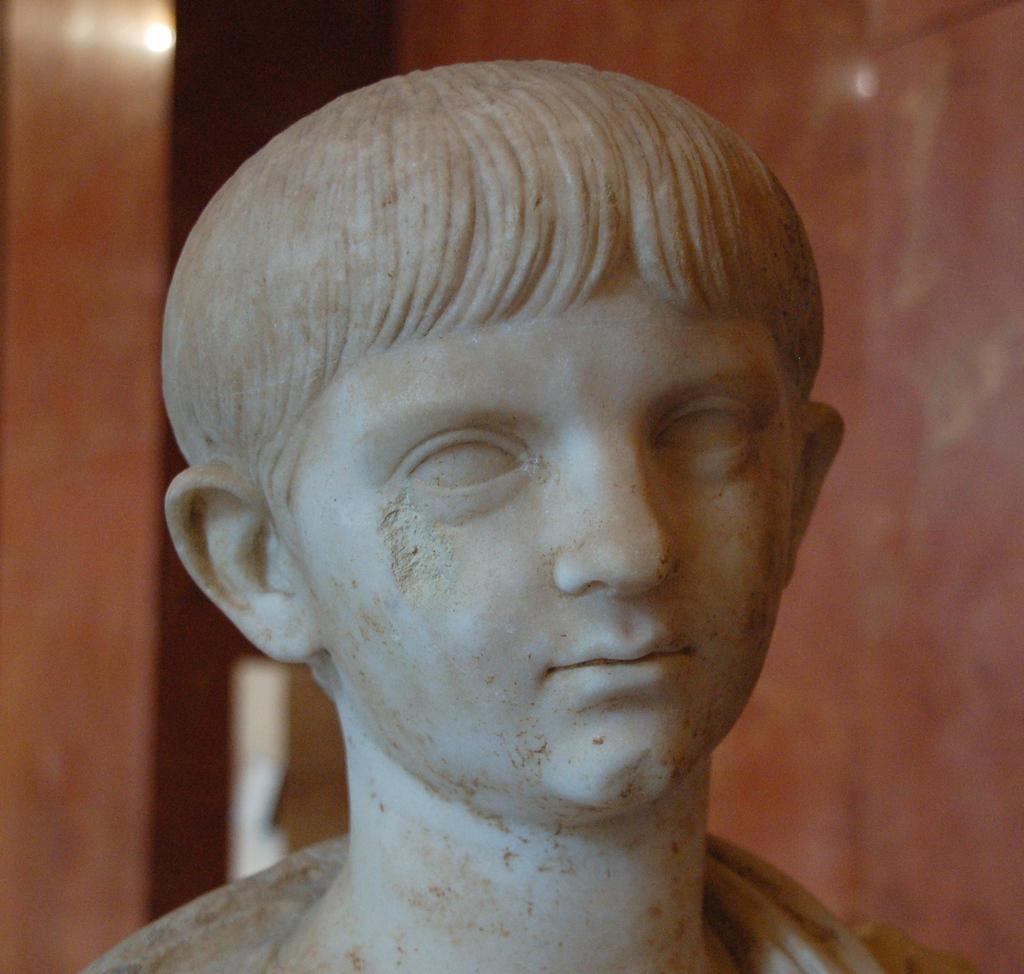In one or two sentences, can you explain what this image depicts? In this picture we can see a person statue and in the background we can see a wall. 